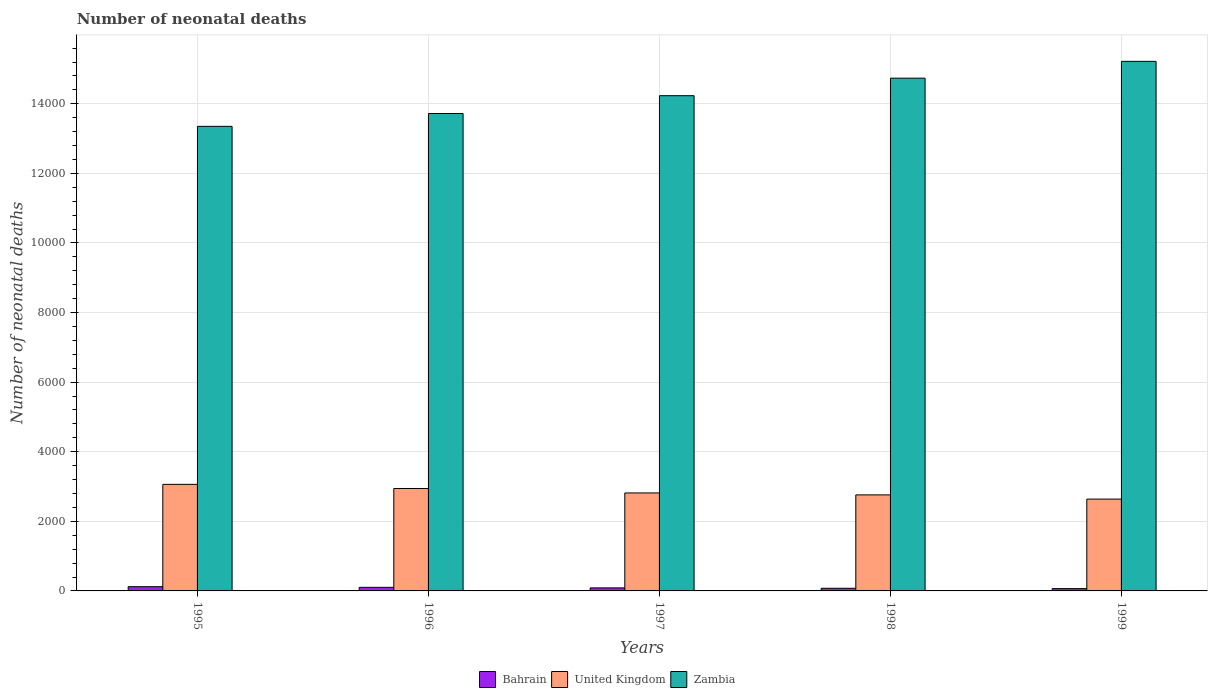How many different coloured bars are there?
Offer a very short reply. 3. Are the number of bars on each tick of the X-axis equal?
Keep it short and to the point. Yes. How many bars are there on the 4th tick from the left?
Keep it short and to the point. 3. What is the number of neonatal deaths in in United Kingdom in 1998?
Your answer should be compact. 2760. Across all years, what is the maximum number of neonatal deaths in in Bahrain?
Your answer should be very brief. 122. Across all years, what is the minimum number of neonatal deaths in in Zambia?
Provide a short and direct response. 1.34e+04. In which year was the number of neonatal deaths in in Zambia maximum?
Give a very brief answer. 1999. In which year was the number of neonatal deaths in in Zambia minimum?
Offer a very short reply. 1995. What is the total number of neonatal deaths in in Zambia in the graph?
Offer a very short reply. 7.13e+04. What is the difference between the number of neonatal deaths in in United Kingdom in 1995 and that in 1997?
Your answer should be very brief. 247. What is the difference between the number of neonatal deaths in in Bahrain in 1997 and the number of neonatal deaths in in United Kingdom in 1999?
Provide a succinct answer. -2552. What is the average number of neonatal deaths in in Zambia per year?
Provide a short and direct response. 1.43e+04. In the year 1997, what is the difference between the number of neonatal deaths in in Bahrain and number of neonatal deaths in in Zambia?
Ensure brevity in your answer.  -1.41e+04. In how many years, is the number of neonatal deaths in in United Kingdom greater than 7200?
Your response must be concise. 0. What is the ratio of the number of neonatal deaths in in United Kingdom in 1996 to that in 1998?
Provide a succinct answer. 1.07. Is the difference between the number of neonatal deaths in in Bahrain in 1998 and 1999 greater than the difference between the number of neonatal deaths in in Zambia in 1998 and 1999?
Make the answer very short. Yes. What is the difference between the highest and the second highest number of neonatal deaths in in Bahrain?
Provide a succinct answer. 19. What is the difference between the highest and the lowest number of neonatal deaths in in Bahrain?
Keep it short and to the point. 56. What does the 1st bar from the left in 1997 represents?
Offer a terse response. Bahrain. What does the 2nd bar from the right in 1996 represents?
Offer a very short reply. United Kingdom. How many bars are there?
Ensure brevity in your answer.  15. How many years are there in the graph?
Provide a succinct answer. 5. How are the legend labels stacked?
Keep it short and to the point. Horizontal. What is the title of the graph?
Make the answer very short. Number of neonatal deaths. What is the label or title of the Y-axis?
Offer a very short reply. Number of neonatal deaths. What is the Number of neonatal deaths of Bahrain in 1995?
Give a very brief answer. 122. What is the Number of neonatal deaths of United Kingdom in 1995?
Provide a succinct answer. 3063. What is the Number of neonatal deaths in Zambia in 1995?
Ensure brevity in your answer.  1.34e+04. What is the Number of neonatal deaths in Bahrain in 1996?
Provide a succinct answer. 103. What is the Number of neonatal deaths in United Kingdom in 1996?
Keep it short and to the point. 2944. What is the Number of neonatal deaths of Zambia in 1996?
Make the answer very short. 1.37e+04. What is the Number of neonatal deaths of United Kingdom in 1997?
Your response must be concise. 2816. What is the Number of neonatal deaths of Zambia in 1997?
Ensure brevity in your answer.  1.42e+04. What is the Number of neonatal deaths of United Kingdom in 1998?
Your answer should be very brief. 2760. What is the Number of neonatal deaths in Zambia in 1998?
Your response must be concise. 1.47e+04. What is the Number of neonatal deaths in Bahrain in 1999?
Provide a short and direct response. 66. What is the Number of neonatal deaths in United Kingdom in 1999?
Give a very brief answer. 2639. What is the Number of neonatal deaths in Zambia in 1999?
Keep it short and to the point. 1.52e+04. Across all years, what is the maximum Number of neonatal deaths of Bahrain?
Offer a terse response. 122. Across all years, what is the maximum Number of neonatal deaths of United Kingdom?
Ensure brevity in your answer.  3063. Across all years, what is the maximum Number of neonatal deaths of Zambia?
Provide a succinct answer. 1.52e+04. Across all years, what is the minimum Number of neonatal deaths in Bahrain?
Make the answer very short. 66. Across all years, what is the minimum Number of neonatal deaths of United Kingdom?
Ensure brevity in your answer.  2639. Across all years, what is the minimum Number of neonatal deaths in Zambia?
Provide a succinct answer. 1.34e+04. What is the total Number of neonatal deaths in Bahrain in the graph?
Provide a succinct answer. 454. What is the total Number of neonatal deaths in United Kingdom in the graph?
Give a very brief answer. 1.42e+04. What is the total Number of neonatal deaths of Zambia in the graph?
Offer a very short reply. 7.13e+04. What is the difference between the Number of neonatal deaths in United Kingdom in 1995 and that in 1996?
Offer a very short reply. 119. What is the difference between the Number of neonatal deaths of Zambia in 1995 and that in 1996?
Offer a very short reply. -369. What is the difference between the Number of neonatal deaths in United Kingdom in 1995 and that in 1997?
Give a very brief answer. 247. What is the difference between the Number of neonatal deaths of Zambia in 1995 and that in 1997?
Provide a short and direct response. -881. What is the difference between the Number of neonatal deaths of Bahrain in 1995 and that in 1998?
Give a very brief answer. 46. What is the difference between the Number of neonatal deaths in United Kingdom in 1995 and that in 1998?
Provide a short and direct response. 303. What is the difference between the Number of neonatal deaths of Zambia in 1995 and that in 1998?
Your answer should be very brief. -1385. What is the difference between the Number of neonatal deaths of United Kingdom in 1995 and that in 1999?
Your response must be concise. 424. What is the difference between the Number of neonatal deaths of Zambia in 1995 and that in 1999?
Ensure brevity in your answer.  -1868. What is the difference between the Number of neonatal deaths of Bahrain in 1996 and that in 1997?
Your answer should be compact. 16. What is the difference between the Number of neonatal deaths in United Kingdom in 1996 and that in 1997?
Your answer should be compact. 128. What is the difference between the Number of neonatal deaths in Zambia in 1996 and that in 1997?
Offer a terse response. -512. What is the difference between the Number of neonatal deaths of Bahrain in 1996 and that in 1998?
Make the answer very short. 27. What is the difference between the Number of neonatal deaths of United Kingdom in 1996 and that in 1998?
Your response must be concise. 184. What is the difference between the Number of neonatal deaths in Zambia in 1996 and that in 1998?
Provide a short and direct response. -1016. What is the difference between the Number of neonatal deaths in Bahrain in 1996 and that in 1999?
Your response must be concise. 37. What is the difference between the Number of neonatal deaths in United Kingdom in 1996 and that in 1999?
Offer a terse response. 305. What is the difference between the Number of neonatal deaths of Zambia in 1996 and that in 1999?
Ensure brevity in your answer.  -1499. What is the difference between the Number of neonatal deaths in Bahrain in 1997 and that in 1998?
Provide a short and direct response. 11. What is the difference between the Number of neonatal deaths in United Kingdom in 1997 and that in 1998?
Offer a terse response. 56. What is the difference between the Number of neonatal deaths in Zambia in 1997 and that in 1998?
Your answer should be compact. -504. What is the difference between the Number of neonatal deaths of United Kingdom in 1997 and that in 1999?
Provide a short and direct response. 177. What is the difference between the Number of neonatal deaths of Zambia in 1997 and that in 1999?
Ensure brevity in your answer.  -987. What is the difference between the Number of neonatal deaths of Bahrain in 1998 and that in 1999?
Keep it short and to the point. 10. What is the difference between the Number of neonatal deaths in United Kingdom in 1998 and that in 1999?
Your answer should be very brief. 121. What is the difference between the Number of neonatal deaths of Zambia in 1998 and that in 1999?
Your answer should be compact. -483. What is the difference between the Number of neonatal deaths in Bahrain in 1995 and the Number of neonatal deaths in United Kingdom in 1996?
Your response must be concise. -2822. What is the difference between the Number of neonatal deaths in Bahrain in 1995 and the Number of neonatal deaths in Zambia in 1996?
Your answer should be very brief. -1.36e+04. What is the difference between the Number of neonatal deaths in United Kingdom in 1995 and the Number of neonatal deaths in Zambia in 1996?
Give a very brief answer. -1.07e+04. What is the difference between the Number of neonatal deaths in Bahrain in 1995 and the Number of neonatal deaths in United Kingdom in 1997?
Ensure brevity in your answer.  -2694. What is the difference between the Number of neonatal deaths in Bahrain in 1995 and the Number of neonatal deaths in Zambia in 1997?
Give a very brief answer. -1.41e+04. What is the difference between the Number of neonatal deaths of United Kingdom in 1995 and the Number of neonatal deaths of Zambia in 1997?
Provide a succinct answer. -1.12e+04. What is the difference between the Number of neonatal deaths in Bahrain in 1995 and the Number of neonatal deaths in United Kingdom in 1998?
Your response must be concise. -2638. What is the difference between the Number of neonatal deaths of Bahrain in 1995 and the Number of neonatal deaths of Zambia in 1998?
Your answer should be very brief. -1.46e+04. What is the difference between the Number of neonatal deaths of United Kingdom in 1995 and the Number of neonatal deaths of Zambia in 1998?
Ensure brevity in your answer.  -1.17e+04. What is the difference between the Number of neonatal deaths in Bahrain in 1995 and the Number of neonatal deaths in United Kingdom in 1999?
Make the answer very short. -2517. What is the difference between the Number of neonatal deaths of Bahrain in 1995 and the Number of neonatal deaths of Zambia in 1999?
Provide a succinct answer. -1.51e+04. What is the difference between the Number of neonatal deaths of United Kingdom in 1995 and the Number of neonatal deaths of Zambia in 1999?
Offer a very short reply. -1.22e+04. What is the difference between the Number of neonatal deaths in Bahrain in 1996 and the Number of neonatal deaths in United Kingdom in 1997?
Your answer should be very brief. -2713. What is the difference between the Number of neonatal deaths in Bahrain in 1996 and the Number of neonatal deaths in Zambia in 1997?
Provide a short and direct response. -1.41e+04. What is the difference between the Number of neonatal deaths in United Kingdom in 1996 and the Number of neonatal deaths in Zambia in 1997?
Provide a succinct answer. -1.13e+04. What is the difference between the Number of neonatal deaths in Bahrain in 1996 and the Number of neonatal deaths in United Kingdom in 1998?
Your response must be concise. -2657. What is the difference between the Number of neonatal deaths of Bahrain in 1996 and the Number of neonatal deaths of Zambia in 1998?
Give a very brief answer. -1.46e+04. What is the difference between the Number of neonatal deaths of United Kingdom in 1996 and the Number of neonatal deaths of Zambia in 1998?
Your response must be concise. -1.18e+04. What is the difference between the Number of neonatal deaths of Bahrain in 1996 and the Number of neonatal deaths of United Kingdom in 1999?
Your response must be concise. -2536. What is the difference between the Number of neonatal deaths of Bahrain in 1996 and the Number of neonatal deaths of Zambia in 1999?
Provide a short and direct response. -1.51e+04. What is the difference between the Number of neonatal deaths of United Kingdom in 1996 and the Number of neonatal deaths of Zambia in 1999?
Your answer should be very brief. -1.23e+04. What is the difference between the Number of neonatal deaths of Bahrain in 1997 and the Number of neonatal deaths of United Kingdom in 1998?
Your response must be concise. -2673. What is the difference between the Number of neonatal deaths of Bahrain in 1997 and the Number of neonatal deaths of Zambia in 1998?
Provide a succinct answer. -1.46e+04. What is the difference between the Number of neonatal deaths of United Kingdom in 1997 and the Number of neonatal deaths of Zambia in 1998?
Your answer should be compact. -1.19e+04. What is the difference between the Number of neonatal deaths of Bahrain in 1997 and the Number of neonatal deaths of United Kingdom in 1999?
Keep it short and to the point. -2552. What is the difference between the Number of neonatal deaths in Bahrain in 1997 and the Number of neonatal deaths in Zambia in 1999?
Offer a very short reply. -1.51e+04. What is the difference between the Number of neonatal deaths of United Kingdom in 1997 and the Number of neonatal deaths of Zambia in 1999?
Make the answer very short. -1.24e+04. What is the difference between the Number of neonatal deaths in Bahrain in 1998 and the Number of neonatal deaths in United Kingdom in 1999?
Your response must be concise. -2563. What is the difference between the Number of neonatal deaths of Bahrain in 1998 and the Number of neonatal deaths of Zambia in 1999?
Make the answer very short. -1.51e+04. What is the difference between the Number of neonatal deaths of United Kingdom in 1998 and the Number of neonatal deaths of Zambia in 1999?
Offer a terse response. -1.25e+04. What is the average Number of neonatal deaths in Bahrain per year?
Provide a short and direct response. 90.8. What is the average Number of neonatal deaths in United Kingdom per year?
Make the answer very short. 2844.4. What is the average Number of neonatal deaths in Zambia per year?
Give a very brief answer. 1.43e+04. In the year 1995, what is the difference between the Number of neonatal deaths in Bahrain and Number of neonatal deaths in United Kingdom?
Your answer should be very brief. -2941. In the year 1995, what is the difference between the Number of neonatal deaths in Bahrain and Number of neonatal deaths in Zambia?
Your answer should be compact. -1.32e+04. In the year 1995, what is the difference between the Number of neonatal deaths of United Kingdom and Number of neonatal deaths of Zambia?
Your response must be concise. -1.03e+04. In the year 1996, what is the difference between the Number of neonatal deaths of Bahrain and Number of neonatal deaths of United Kingdom?
Offer a very short reply. -2841. In the year 1996, what is the difference between the Number of neonatal deaths in Bahrain and Number of neonatal deaths in Zambia?
Give a very brief answer. -1.36e+04. In the year 1996, what is the difference between the Number of neonatal deaths of United Kingdom and Number of neonatal deaths of Zambia?
Offer a terse response. -1.08e+04. In the year 1997, what is the difference between the Number of neonatal deaths in Bahrain and Number of neonatal deaths in United Kingdom?
Provide a short and direct response. -2729. In the year 1997, what is the difference between the Number of neonatal deaths of Bahrain and Number of neonatal deaths of Zambia?
Your response must be concise. -1.41e+04. In the year 1997, what is the difference between the Number of neonatal deaths of United Kingdom and Number of neonatal deaths of Zambia?
Keep it short and to the point. -1.14e+04. In the year 1998, what is the difference between the Number of neonatal deaths of Bahrain and Number of neonatal deaths of United Kingdom?
Offer a terse response. -2684. In the year 1998, what is the difference between the Number of neonatal deaths in Bahrain and Number of neonatal deaths in Zambia?
Offer a very short reply. -1.47e+04. In the year 1998, what is the difference between the Number of neonatal deaths of United Kingdom and Number of neonatal deaths of Zambia?
Keep it short and to the point. -1.20e+04. In the year 1999, what is the difference between the Number of neonatal deaths of Bahrain and Number of neonatal deaths of United Kingdom?
Make the answer very short. -2573. In the year 1999, what is the difference between the Number of neonatal deaths of Bahrain and Number of neonatal deaths of Zambia?
Provide a short and direct response. -1.52e+04. In the year 1999, what is the difference between the Number of neonatal deaths in United Kingdom and Number of neonatal deaths in Zambia?
Offer a very short reply. -1.26e+04. What is the ratio of the Number of neonatal deaths in Bahrain in 1995 to that in 1996?
Keep it short and to the point. 1.18. What is the ratio of the Number of neonatal deaths of United Kingdom in 1995 to that in 1996?
Give a very brief answer. 1.04. What is the ratio of the Number of neonatal deaths of Zambia in 1995 to that in 1996?
Keep it short and to the point. 0.97. What is the ratio of the Number of neonatal deaths in Bahrain in 1995 to that in 1997?
Ensure brevity in your answer.  1.4. What is the ratio of the Number of neonatal deaths of United Kingdom in 1995 to that in 1997?
Your answer should be very brief. 1.09. What is the ratio of the Number of neonatal deaths of Zambia in 1995 to that in 1997?
Give a very brief answer. 0.94. What is the ratio of the Number of neonatal deaths in Bahrain in 1995 to that in 1998?
Your answer should be compact. 1.61. What is the ratio of the Number of neonatal deaths in United Kingdom in 1995 to that in 1998?
Provide a succinct answer. 1.11. What is the ratio of the Number of neonatal deaths in Zambia in 1995 to that in 1998?
Offer a terse response. 0.91. What is the ratio of the Number of neonatal deaths of Bahrain in 1995 to that in 1999?
Your answer should be very brief. 1.85. What is the ratio of the Number of neonatal deaths of United Kingdom in 1995 to that in 1999?
Offer a very short reply. 1.16. What is the ratio of the Number of neonatal deaths in Zambia in 1995 to that in 1999?
Offer a very short reply. 0.88. What is the ratio of the Number of neonatal deaths in Bahrain in 1996 to that in 1997?
Offer a terse response. 1.18. What is the ratio of the Number of neonatal deaths in United Kingdom in 1996 to that in 1997?
Give a very brief answer. 1.05. What is the ratio of the Number of neonatal deaths in Zambia in 1996 to that in 1997?
Your answer should be compact. 0.96. What is the ratio of the Number of neonatal deaths in Bahrain in 1996 to that in 1998?
Offer a terse response. 1.36. What is the ratio of the Number of neonatal deaths of United Kingdom in 1996 to that in 1998?
Ensure brevity in your answer.  1.07. What is the ratio of the Number of neonatal deaths of Zambia in 1996 to that in 1998?
Offer a terse response. 0.93. What is the ratio of the Number of neonatal deaths in Bahrain in 1996 to that in 1999?
Give a very brief answer. 1.56. What is the ratio of the Number of neonatal deaths of United Kingdom in 1996 to that in 1999?
Give a very brief answer. 1.12. What is the ratio of the Number of neonatal deaths in Zambia in 1996 to that in 1999?
Your response must be concise. 0.9. What is the ratio of the Number of neonatal deaths of Bahrain in 1997 to that in 1998?
Ensure brevity in your answer.  1.14. What is the ratio of the Number of neonatal deaths of United Kingdom in 1997 to that in 1998?
Your answer should be very brief. 1.02. What is the ratio of the Number of neonatal deaths of Zambia in 1997 to that in 1998?
Make the answer very short. 0.97. What is the ratio of the Number of neonatal deaths in Bahrain in 1997 to that in 1999?
Provide a succinct answer. 1.32. What is the ratio of the Number of neonatal deaths in United Kingdom in 1997 to that in 1999?
Your response must be concise. 1.07. What is the ratio of the Number of neonatal deaths of Zambia in 1997 to that in 1999?
Offer a very short reply. 0.94. What is the ratio of the Number of neonatal deaths of Bahrain in 1998 to that in 1999?
Ensure brevity in your answer.  1.15. What is the ratio of the Number of neonatal deaths of United Kingdom in 1998 to that in 1999?
Ensure brevity in your answer.  1.05. What is the ratio of the Number of neonatal deaths of Zambia in 1998 to that in 1999?
Offer a terse response. 0.97. What is the difference between the highest and the second highest Number of neonatal deaths in Bahrain?
Provide a short and direct response. 19. What is the difference between the highest and the second highest Number of neonatal deaths of United Kingdom?
Ensure brevity in your answer.  119. What is the difference between the highest and the second highest Number of neonatal deaths in Zambia?
Offer a terse response. 483. What is the difference between the highest and the lowest Number of neonatal deaths of Bahrain?
Offer a very short reply. 56. What is the difference between the highest and the lowest Number of neonatal deaths in United Kingdom?
Offer a terse response. 424. What is the difference between the highest and the lowest Number of neonatal deaths of Zambia?
Provide a succinct answer. 1868. 